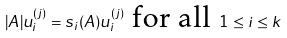Convert formula to latex. <formula><loc_0><loc_0><loc_500><loc_500>| A | u ^ { ( j ) } _ { i } = s _ { i } ( A ) u ^ { ( j ) } _ { i } \text { for all } 1 \leq i \leq k</formula> 